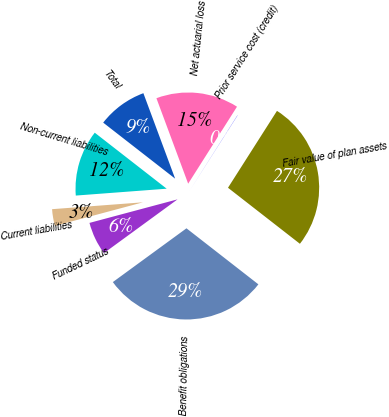Convert chart. <chart><loc_0><loc_0><loc_500><loc_500><pie_chart><fcel>Fair value of plan assets<fcel>Benefit obligations<fcel>Funded status<fcel>Current liabilities<fcel>Non-current liabilities<fcel>Total<fcel>Net actuarial loss<fcel>Prior service cost (credit)<nl><fcel>26.51%<fcel>29.43%<fcel>5.88%<fcel>2.96%<fcel>11.73%<fcel>8.81%<fcel>14.66%<fcel>0.03%<nl></chart> 